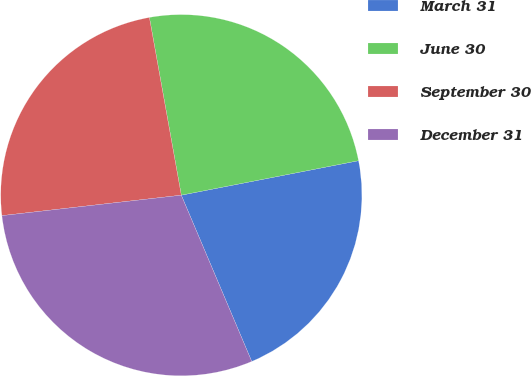<chart> <loc_0><loc_0><loc_500><loc_500><pie_chart><fcel>March 31<fcel>June 30<fcel>September 30<fcel>December 31<nl><fcel>21.68%<fcel>24.77%<fcel>23.98%<fcel>29.57%<nl></chart> 